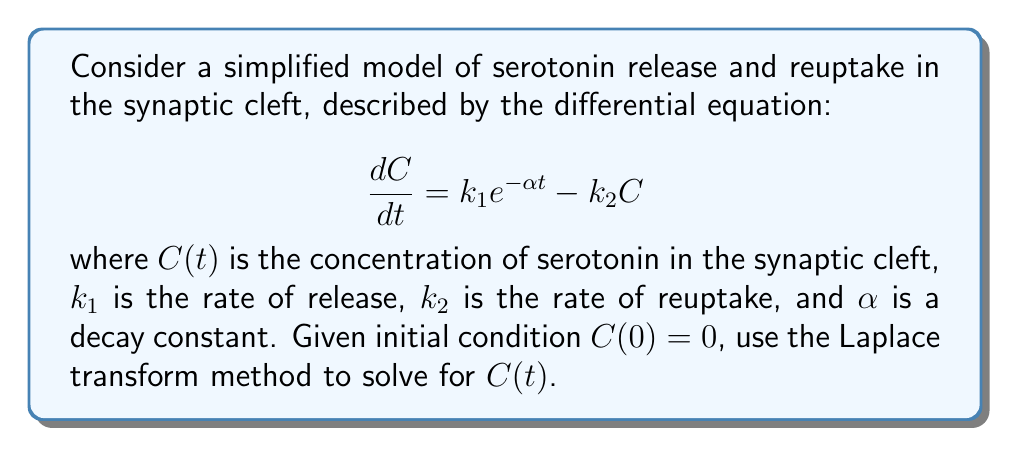Can you solve this math problem? 1) First, let's apply the Laplace transform to both sides of the equation:

   $$\mathcal{L}\left\{\frac{dC}{dt}\right\} = \mathcal{L}\{k_1 e^{-\alpha t} - k_2 C\}$$

2) Using the linearity property and the Laplace transform of an exponential function:

   $$s\mathcal{L}\{C\} - C(0) = k_1 \cdot \frac{1}{s+\alpha} - k_2 \mathcal{L}\{C\}$$

3) Substitute $C(0) = 0$ and let $\mathcal{L}\{C\} = \bar{C}(s)$:

   $$s\bar{C}(s) = \frac{k_1}{s+\alpha} - k_2 \bar{C}(s)$$

4) Rearrange to solve for $\bar{C}(s)$:

   $$\bar{C}(s)(s + k_2) = \frac{k_1}{s+\alpha}$$
   
   $$\bar{C}(s) = \frac{k_1}{(s+\alpha)(s+k_2)}$$

5) Use partial fraction decomposition:

   $$\bar{C}(s) = \frac{A}{s+\alpha} + \frac{B}{s+k_2}$$

   where $A = \frac{k_1}{k_2-\alpha}$ and $B = \frac{-k_1}{k_2-\alpha}$

6) Apply the inverse Laplace transform:

   $$C(t) = \mathcal{L}^{-1}\{\bar{C}(s)\} = Ae^{-\alpha t} + Be^{-k_2 t}$$

7) Substitute the values of A and B:

   $$C(t) = \frac{k_1}{k_2-\alpha}(e^{-\alpha t} - e^{-k_2 t})$$

This is the solution for the concentration of serotonin in the synaptic cleft as a function of time.
Answer: $$C(t) = \frac{k_1}{k_2-\alpha}(e^{-\alpha t} - e^{-k_2 t})$$ 